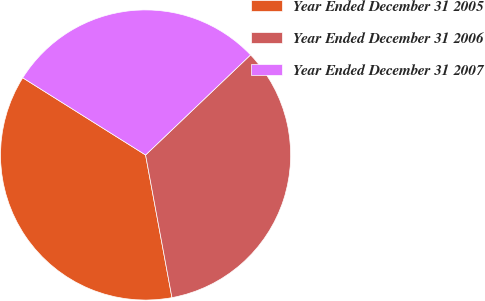Convert chart to OTSL. <chart><loc_0><loc_0><loc_500><loc_500><pie_chart><fcel>Year Ended December 31 2005<fcel>Year Ended December 31 2006<fcel>Year Ended December 31 2007<nl><fcel>36.84%<fcel>34.21%<fcel>28.95%<nl></chart> 